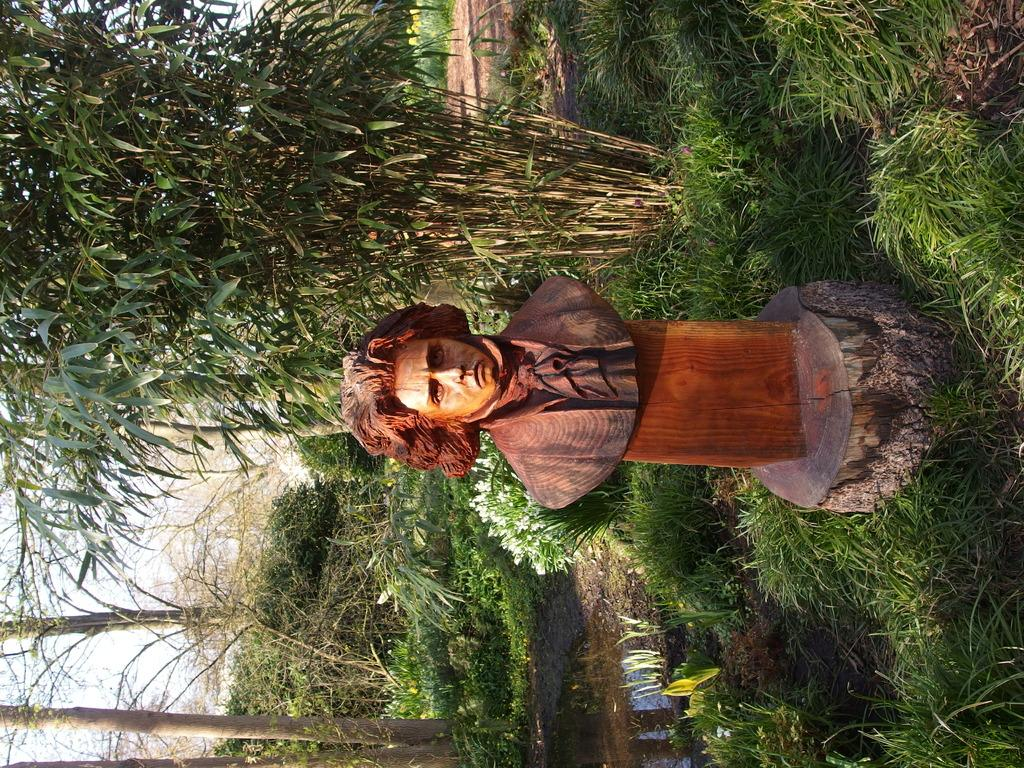What is the main subject in the image? There is a statue of a person in the image. What can be seen in the background of the image? There are trees, plants, grass, and the sky visible in the background of the image. Can you see the border between two countries in the image? There is no border visible in the image; it features a statue and natural elements in the background. 